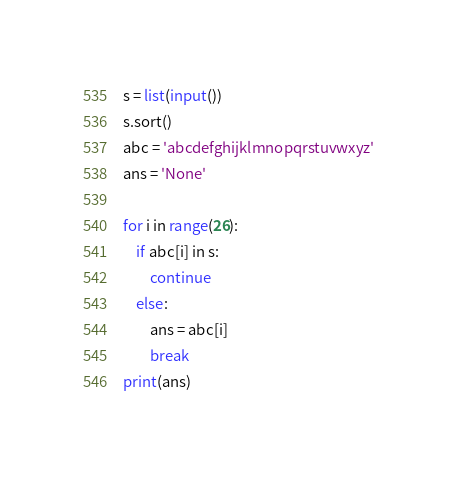<code> <loc_0><loc_0><loc_500><loc_500><_Python_>s = list(input())
s.sort()
abc = 'abcdefghijklmnopqrstuvwxyz'
ans = 'None'

for i in range(26):
	if abc[i] in s:
		continue
	else:
		ans = abc[i]
		break
print(ans)
</code> 